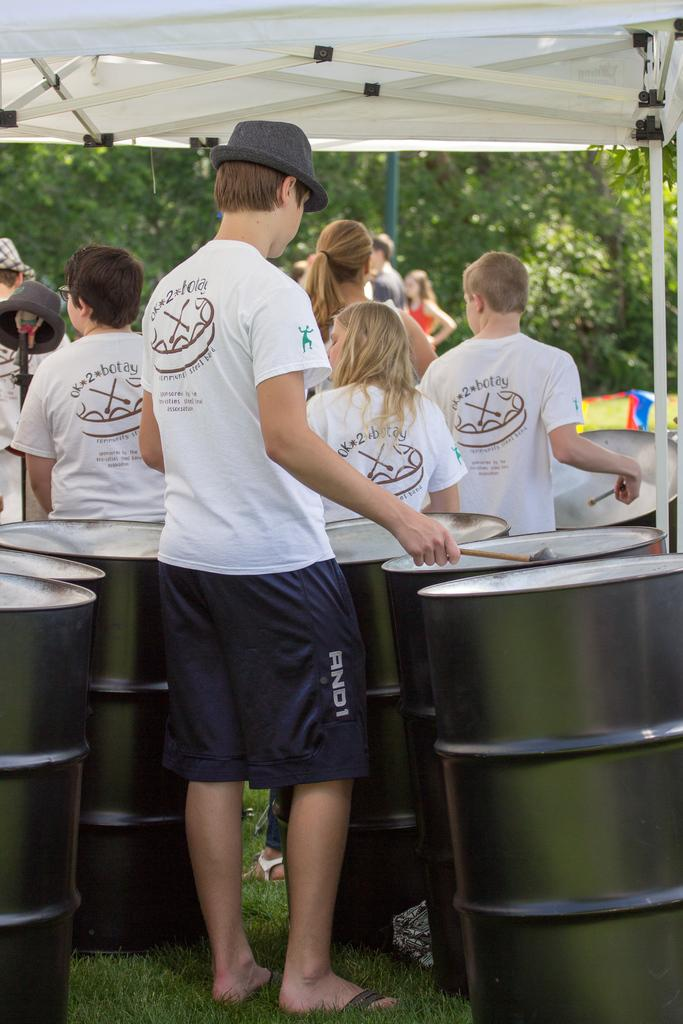<image>
Offer a succinct explanation of the picture presented. A group of teens gathered around some steel drums, all wearing white steel band shirts as uniforms. 